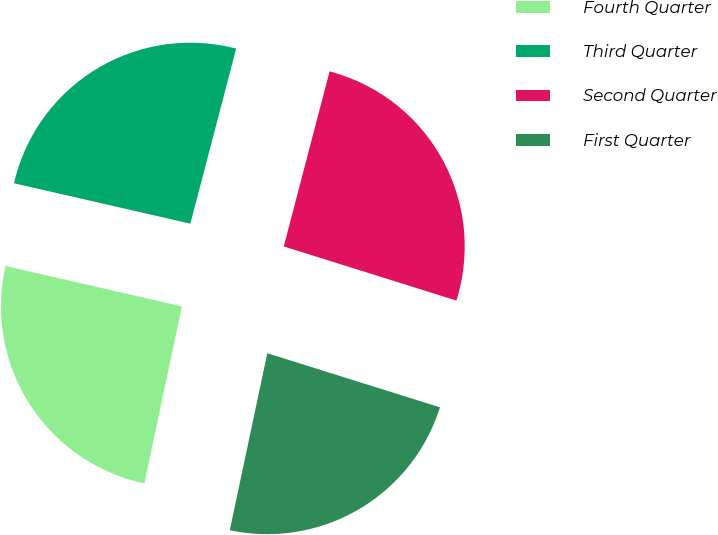Convert chart to OTSL. <chart><loc_0><loc_0><loc_500><loc_500><pie_chart><fcel>Fourth Quarter<fcel>Third Quarter<fcel>Second Quarter<fcel>First Quarter<nl><fcel>25.26%<fcel>25.49%<fcel>25.76%<fcel>23.49%<nl></chart> 